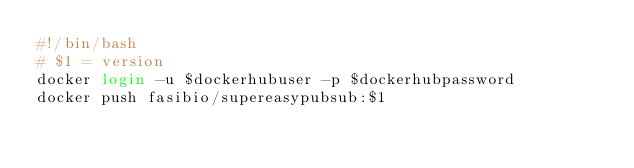Convert code to text. <code><loc_0><loc_0><loc_500><loc_500><_Bash_>#!/bin/bash
# $1 = version
docker login -u $dockerhubuser -p $dockerhubpassword
docker push fasibio/supereasypubsub:$1</code> 